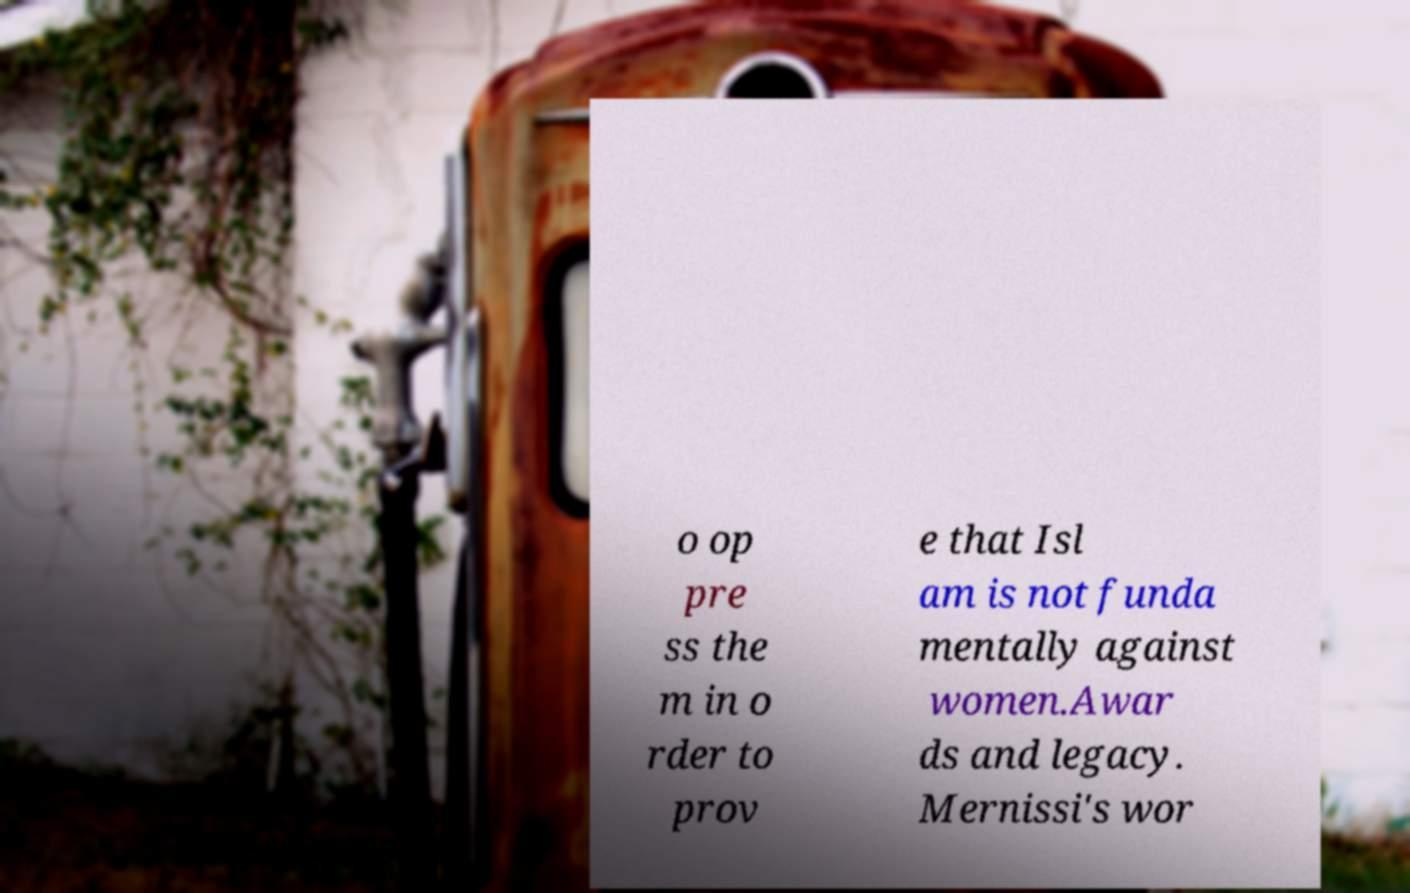I need the written content from this picture converted into text. Can you do that? o op pre ss the m in o rder to prov e that Isl am is not funda mentally against women.Awar ds and legacy. Mernissi's wor 